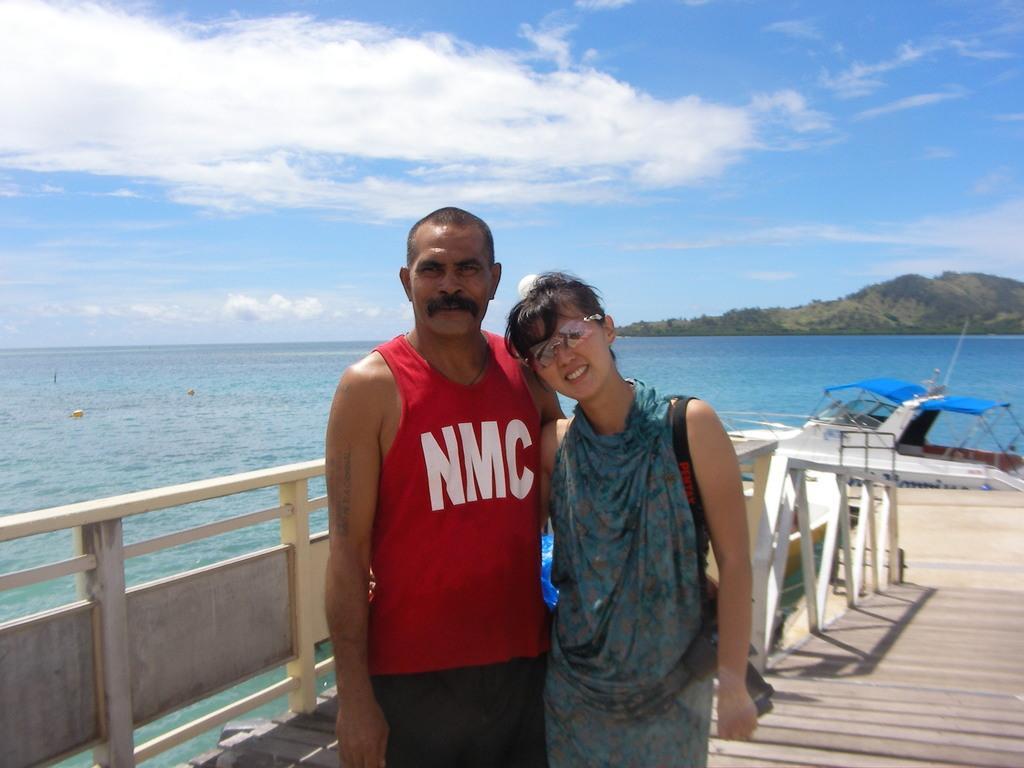Can you describe this image briefly? In the image we can see a man and a woman standing, wearing clothes and the woman is wearing spectacles. Here we can see wooden surface and a wooden fence. Here we can see sea, hill, boat and a cloudy pale blue sky. 